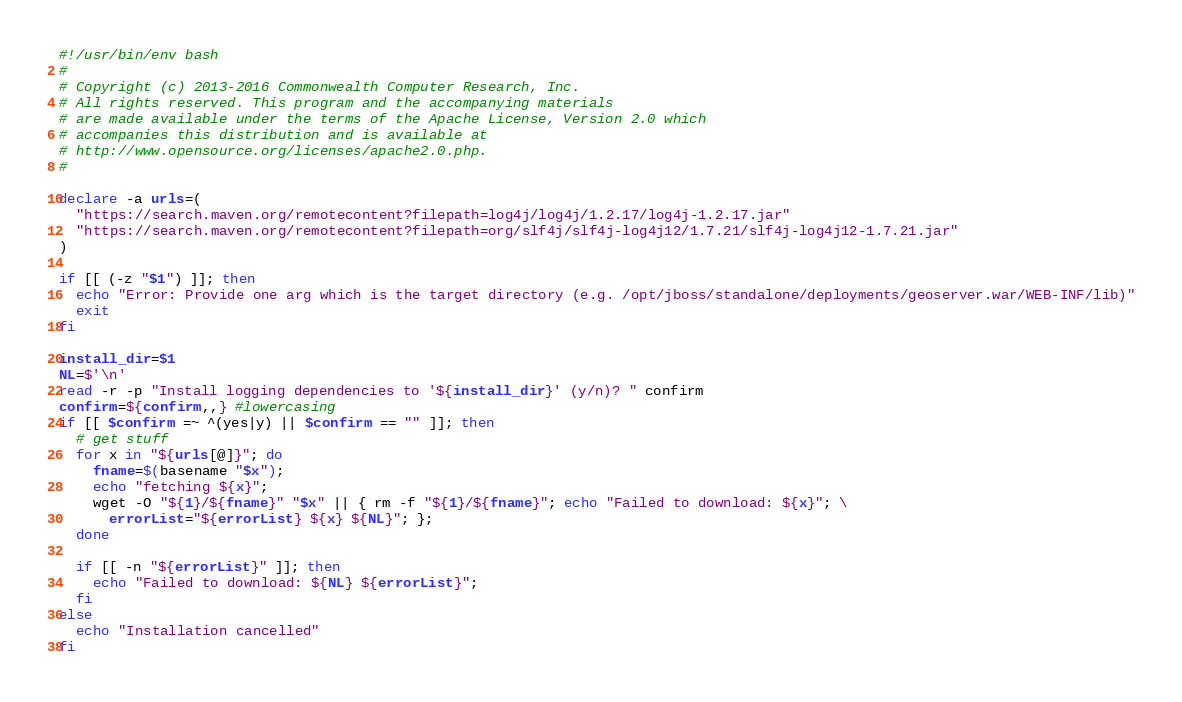<code> <loc_0><loc_0><loc_500><loc_500><_Bash_>#!/usr/bin/env bash
#
# Copyright (c) 2013-2016 Commonwealth Computer Research, Inc.
# All rights reserved. This program and the accompanying materials
# are made available under the terms of the Apache License, Version 2.0 which
# accompanies this distribution and is available at
# http://www.opensource.org/licenses/apache2.0.php.
#

declare -a urls=(
  "https://search.maven.org/remotecontent?filepath=log4j/log4j/1.2.17/log4j-1.2.17.jar"
  "https://search.maven.org/remotecontent?filepath=org/slf4j/slf4j-log4j12/1.7.21/slf4j-log4j12-1.7.21.jar"
)

if [[ (-z "$1") ]]; then
  echo "Error: Provide one arg which is the target directory (e.g. /opt/jboss/standalone/deployments/geoserver.war/WEB-INF/lib)"
  exit
fi

install_dir=$1
NL=$'\n'
read -r -p "Install logging dependencies to '${install_dir}' (y/n)? " confirm
confirm=${confirm,,} #lowercasing
if [[ $confirm =~ ^(yes|y) || $confirm == "" ]]; then
  # get stuff
  for x in "${urls[@]}"; do
    fname=$(basename "$x");
    echo "fetching ${x}";
    wget -O "${1}/${fname}" "$x" || { rm -f "${1}/${fname}"; echo "Failed to download: ${x}"; \
      errorList="${errorList} ${x} ${NL}"; };
  done

  if [[ -n "${errorList}" ]]; then
    echo "Failed to download: ${NL} ${errorList}";
  fi
else
  echo "Installation cancelled"
fi
</code> 